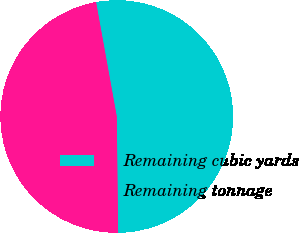<chart> <loc_0><loc_0><loc_500><loc_500><pie_chart><fcel>Remaining cubic yards<fcel>Remaining tonnage<nl><fcel>52.67%<fcel>47.33%<nl></chart> 